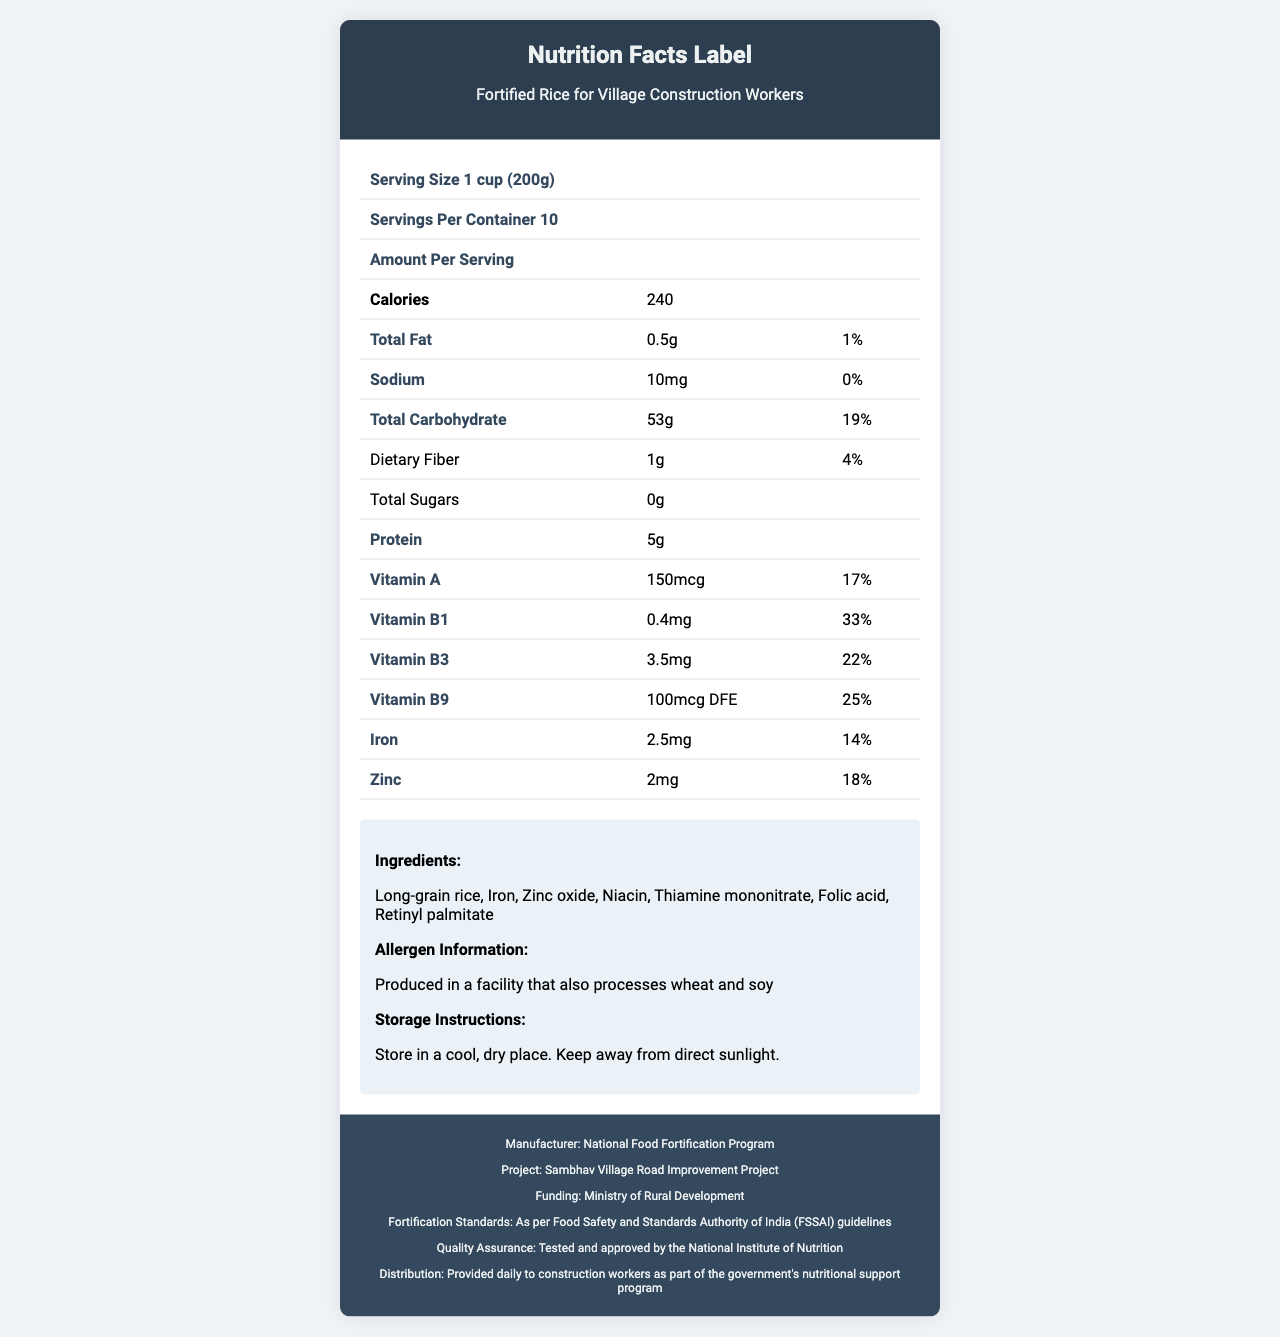what is the product name? The product name is mentioned at the top of the document in the title.
Answer: Fortified Rice for Village Construction Workers what is the serving size of the product? The serving size is listed as "1 cup (200g)" in the table under "Serving Size".
Answer: 1 cup (200g) how many servings are there per container? The number of servings per container is listed as "Servings Per Container 10" in the table.
Answer: 10 how many calories are in one serving? One serving contains 240 calories as specified in the "Calories" row of the table.
Answer: 240 what is the amount of total fat per serving, and what percentage of the daily value does it represent? The amount of total fat per serving is 0.5g, and it represents 1% of the daily value.
Answer: 0.5g, 1% what minerals are included in the fortified rice? A. Iron and Magnesium B. Iron and Zinc C. Calcium and Zinc D. Iron and Calcium The table shows that the fortified rice contains Iron (2.5mg, 14% daily value) and Zinc (2mg, 18% daily value).
Answer: B. Iron and Zinc what vitamins are specifically listed in the nutrition facts? A. Vitamin A, B1, B3, B9 B. Vitamin A, C, D, E B. Vitamin B1, B2, C D. Vitamin A, B6, B9 The vitamins listed in the document are Vitamin A, B1, B3, and B9.
Answer: A. Vitamin A, B1, B3, B9 does this product contain any dietary fiber? The document indicates that each serving contains 1g of dietary fiber, representing 4% of the daily value.
Answer: Yes is there any protein in this product? The document shows that the product contains 5g of protein per serving.
Answer: Yes does the product contain any sugar? The document specifies that the total sugars in the product are 0g.
Answer: No what are the checkbourne types of vitamins in the product? The document explicitly lists Vitamin A, B1, B3, and B9 in the nutritional details.
Answer: Vitamin A, Vitamin B1, Vitamin B3, Vitamin B9 what is the project name for which this fortified rice is provided? The project name is listed at the bottom of the document, near the footer.
Answer: Sambhav Village Road Improvement Project what is the funding source for this project? The funding source is mentioned at the bottom of the document as the "Ministry of Rural Development".
Answer: Ministry of Rural Development who is the manufacturer of this fortified rice? The manufacturer is listed at the bottom of the document as the "National Food Fortification Program".
Answer: National Food Fortification Program what are the storage instructions for this product? The storage instructions state that the product should be stored in a cool, dry place and kept away from direct sunlight.
Answer: Store in a cool, dry place. Keep away from direct sunlight. can we determine the price of this product from the document? The document does not provide any information about the price of the product.
Answer: Cannot be determined what allergen information is provided on the label? The allergen information states that the product is produced in a facility that also processes wheat and soy.
Answer: Produced in a facility that also processes wheat and soy summarize the main idea of the document. The document serves to inform about the nutritional benefits and other important aspects of the fortified rice provided to construction workers involved in the Sambhav Village Road Improvement Project, ensuring transparency and quality standards.
Answer: The document provides nutritional information, ingredients, and other relevant details about the "Fortified Rice for Village Construction Workers." It includes specifics such as serving size, calories, amounts of various nutrients and vitamins, and daily values. Additionally, the document mentions storage instructions, allergen information, and the project details, including the manufacturer, funding source, and quality assurance standards. 